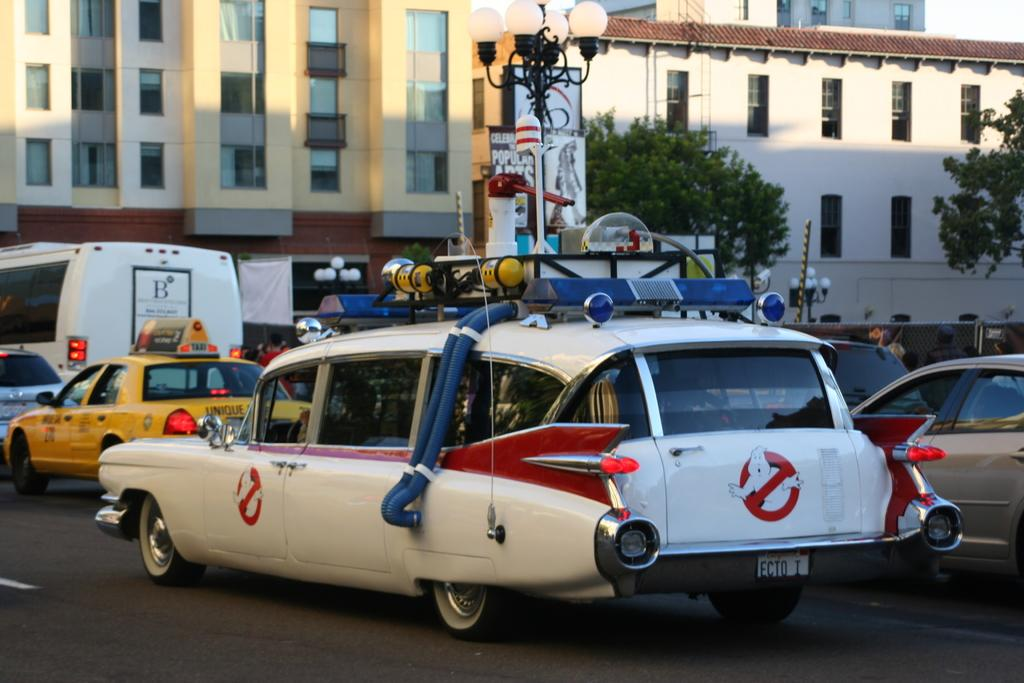What can be seen on the road in the image? There are vehicles parked on the road in the image. What is visible at the bottom of the image? The road is visible at the bottom of the image. What can be seen in the background of the image? There are street lights, trees, and buildings in the background of the image. Where are the rabbits playing in the image? There are no rabbits present in the image. Can you see the sea in the background of the image? The image does not show the sea; it features a road, vehicles, and buildings in an urban setting. 